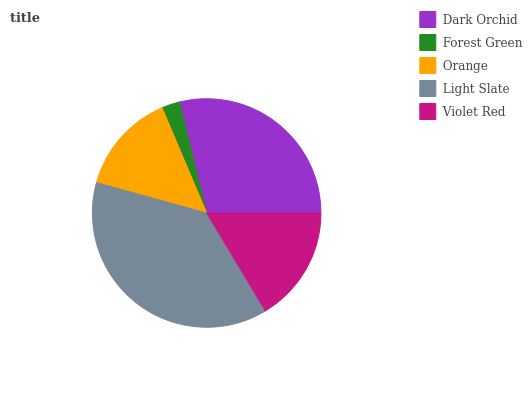Is Forest Green the minimum?
Answer yes or no. Yes. Is Light Slate the maximum?
Answer yes or no. Yes. Is Orange the minimum?
Answer yes or no. No. Is Orange the maximum?
Answer yes or no. No. Is Orange greater than Forest Green?
Answer yes or no. Yes. Is Forest Green less than Orange?
Answer yes or no. Yes. Is Forest Green greater than Orange?
Answer yes or no. No. Is Orange less than Forest Green?
Answer yes or no. No. Is Violet Red the high median?
Answer yes or no. Yes. Is Violet Red the low median?
Answer yes or no. Yes. Is Dark Orchid the high median?
Answer yes or no. No. Is Dark Orchid the low median?
Answer yes or no. No. 